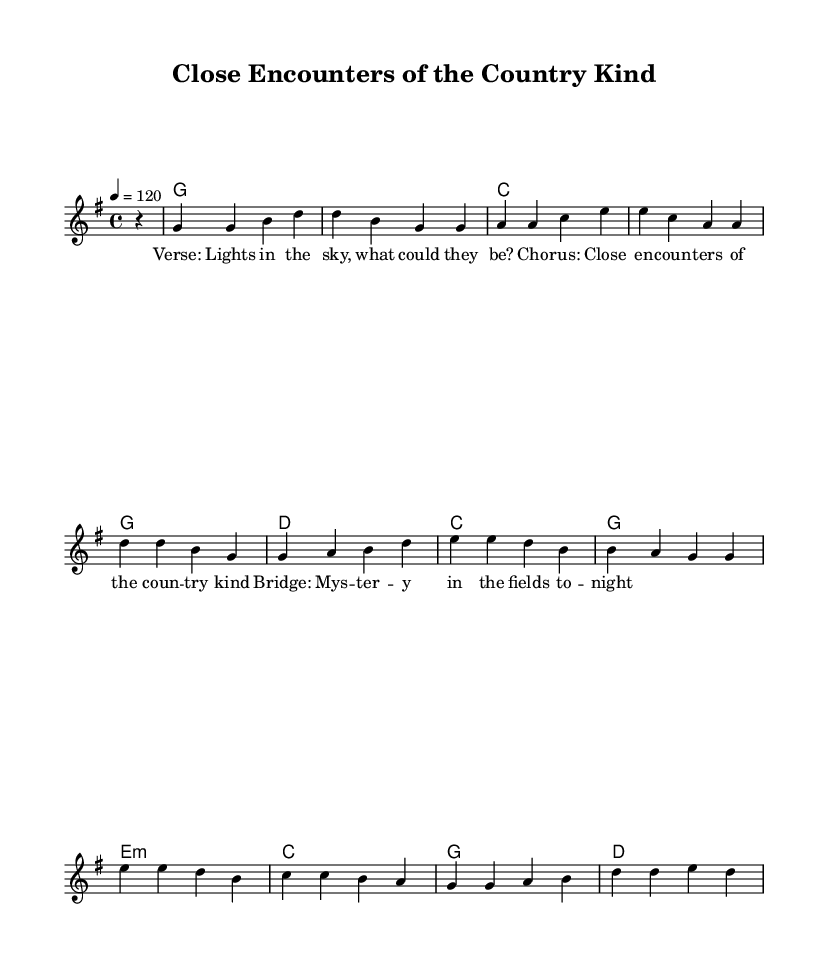What is the key signature of this music? The key signature indicates the number of sharps or flats in a piece. In this sheet music, the key is set to G major, which has one sharp (F#).
Answer: G major What is the time signature of this music? The time signature is indicated at the beginning of the music, after the key signature. In this case, it is shown as 4/4, which means there are four beats per measure and the quarter note gets one beat.
Answer: 4/4 What is the tempo marking for this piece? The tempo marking is specified using the term "tempo" followed by a number, which indicates the beats per minute. Here, it states "4 = 120," meaning there are 120 beats per minute.
Answer: 120 How many measures are there in the bridge section? To find the number of measures, we can count each group of notes separated by vertical bars. The bridge consists of four measures indicating how the music is structured.
Answer: 4 How does the mood of the lyrics relate to the country theme? The lyrics mention "lights in the sky" and "mystery," which evoke feelings of wonder and curiosity often found in country music that deals with storytelling and themes of the unknown. The imagery ties to rural settings, which is a common element in country narratives.
Answer: Wonder and curiosity 